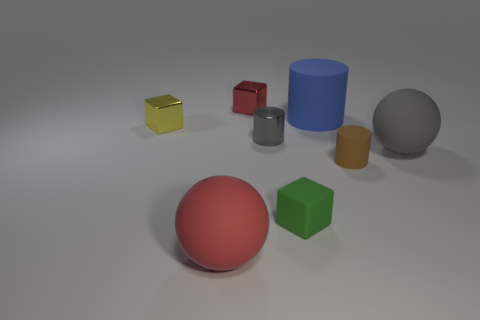What is the material of the small block that is both behind the big gray rubber ball and in front of the big blue matte object?
Give a very brief answer. Metal. There is a tiny red shiny thing; what number of tiny green rubber objects are in front of it?
Ensure brevity in your answer.  1. Are there any other things that are the same size as the blue rubber thing?
Ensure brevity in your answer.  Yes. There is another large sphere that is the same material as the large red ball; what is its color?
Offer a terse response. Gray. Do the big gray thing and the large red thing have the same shape?
Offer a very short reply. Yes. How many small things are both behind the small gray shiny object and on the right side of the small green matte thing?
Your answer should be compact. 0. What number of metallic things are gray balls or small brown objects?
Provide a short and direct response. 0. There is a cylinder left of the rubber cylinder that is behind the gray matte object; what size is it?
Keep it short and to the point. Small. What is the material of the big thing that is the same color as the metallic cylinder?
Provide a succinct answer. Rubber. There is a matte sphere that is behind the small rubber object on the right side of the blue rubber cylinder; are there any small cylinders that are behind it?
Provide a short and direct response. Yes. 